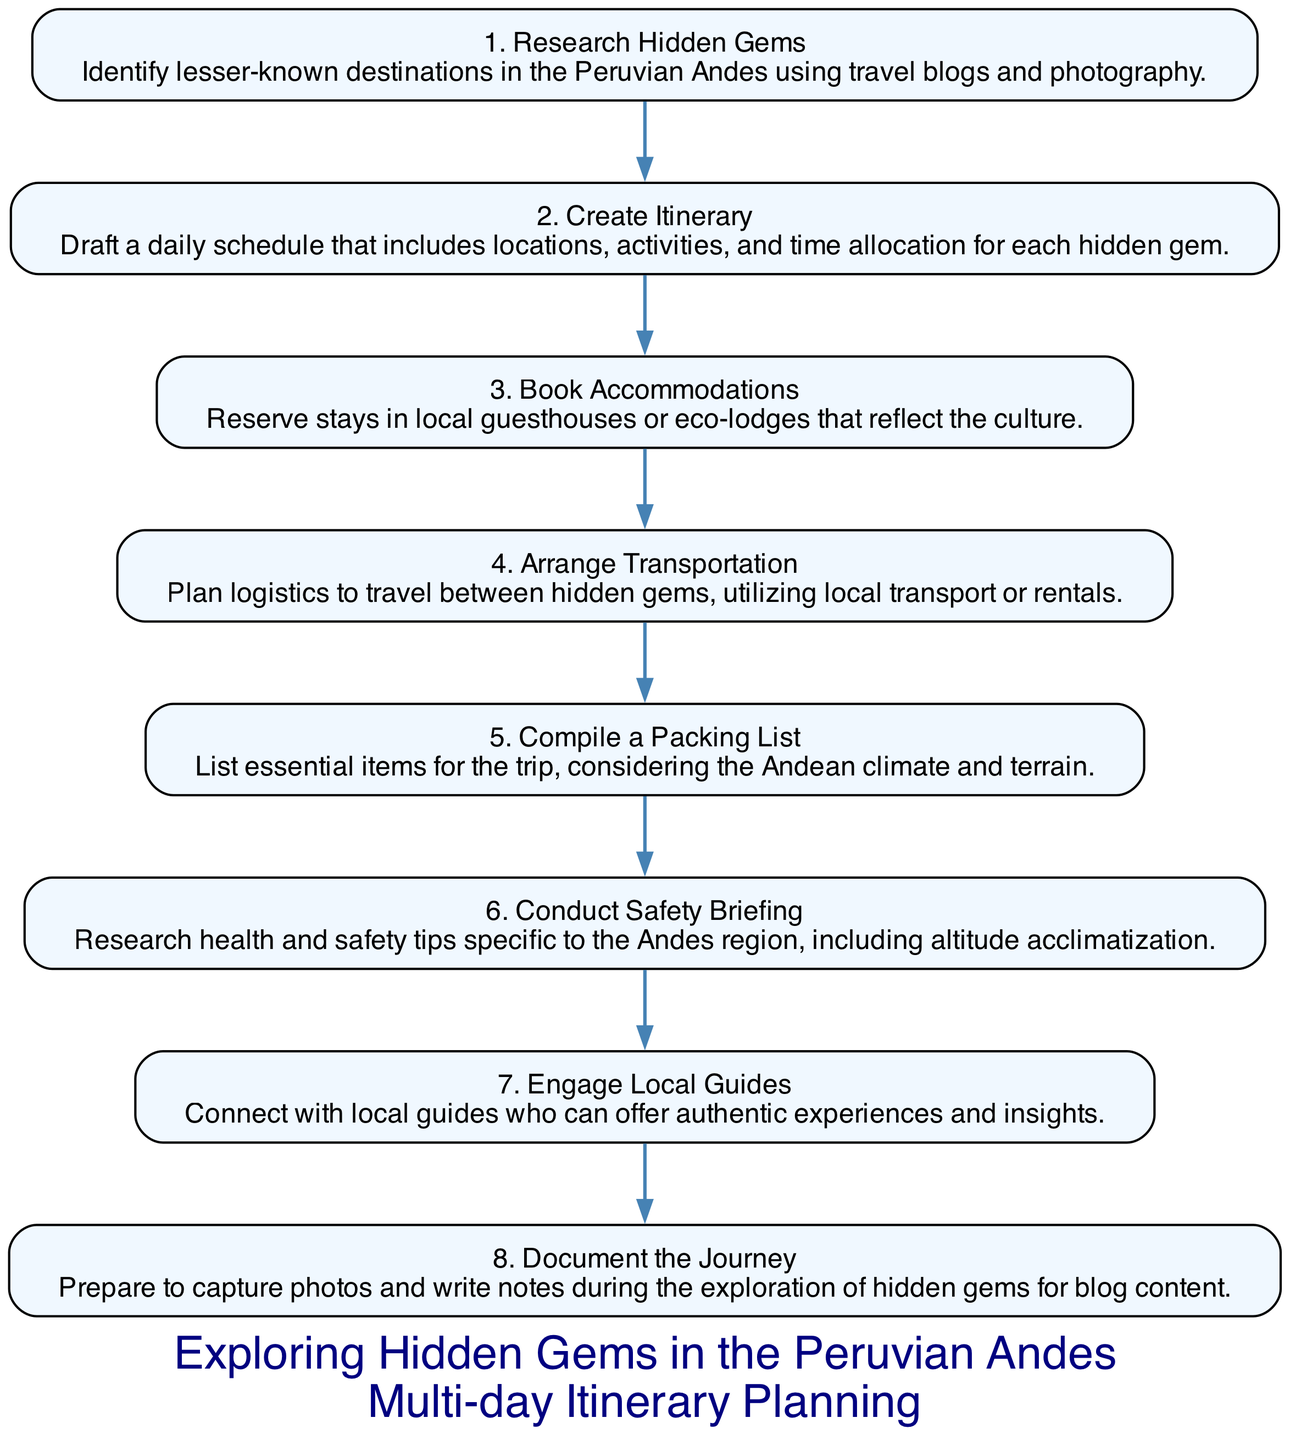What is the first step in planning the itinerary? The first step listed in the diagram is "Research Hidden Gems," which involves identifying lesser-known destinations in the Peruvian Andes using travel blogs and photography.
Answer: Research Hidden Gems How many total steps are included in the itinerary? The diagram includes a total of 8 steps, as indicated by the 8 distinct nodes representing various stages in planning the itinerary.
Answer: 8 What step comes after "Create Itinerary"? Following "Create Itinerary," the next step is "Book Accommodations." This shows the order of actions taken in the planning process.
Answer: Book Accommodations Which step emphasizes engaging with local culture? "Book Accommodations" focuses on reserving stays in local guesthouses or eco-lodges that reflect the culture, highlighting the importance of cultural engagement.
Answer: Book Accommodations What two steps focus on safety? "Conduct Safety Briefing" and "Engage Local Guides" both emphasize safety; the first ensures health and safety tips are researched, while the second connects travelers with local guides for authentic experiences.
Answer: Conduct Safety Briefing, Engage Local Guides What is the last step in the itinerary planning? The last step in the sequence is "Document the Journey," which involves preparing to capture photos and write notes during the exploration for blog content.
Answer: Document the Journey How many steps are there between "Arrange Transportation" and "Document the Journey"? There are 4 steps between "Arrange Transportation" and "Document the Journey," illustrating the sequential nature of the planning process.
Answer: 4 Which step involves creating a list of essential items? The step titled "Compile a Packing List" involves creating a list of essential items needed for the trip, considering the specific conditions of the Andean climate and terrain.
Answer: Compile a Packing List 